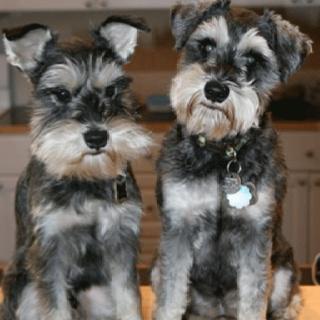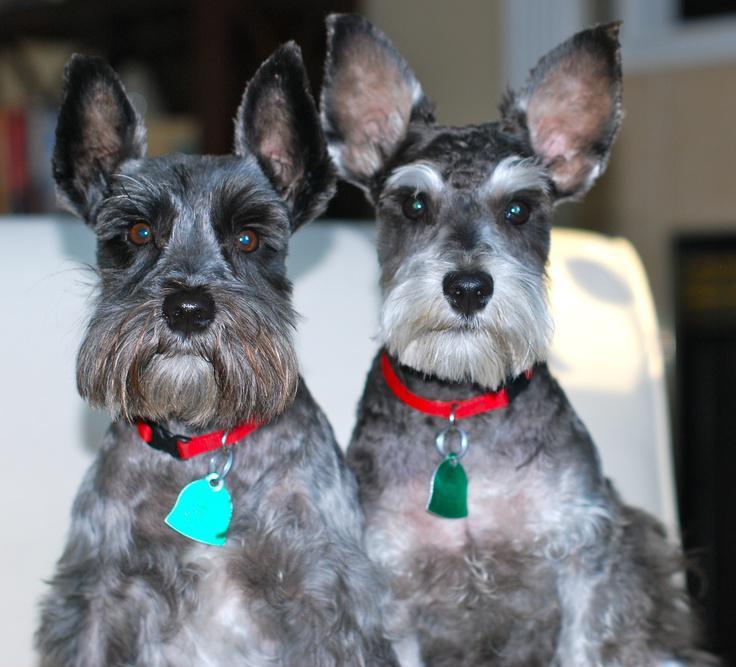The first image is the image on the left, the second image is the image on the right. Evaluate the accuracy of this statement regarding the images: "One dog has a red collar in the image on the left.". Is it true? Answer yes or no. No. The first image is the image on the left, the second image is the image on the right. For the images displayed, is the sentence "An image shows at least one schnauzer dog wearing something bright red." factually correct? Answer yes or no. Yes. 